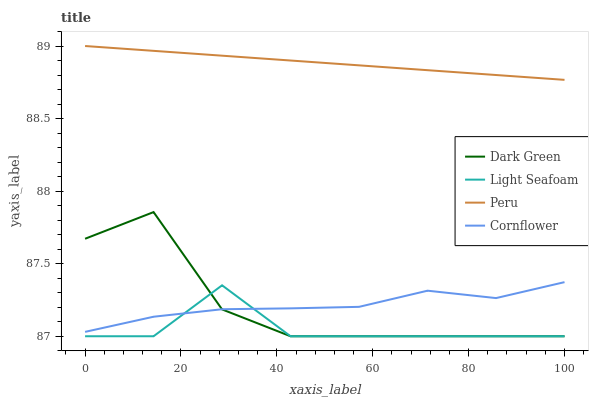Does Light Seafoam have the minimum area under the curve?
Answer yes or no. Yes. Does Peru have the maximum area under the curve?
Answer yes or no. Yes. Does Peru have the minimum area under the curve?
Answer yes or no. No. Does Light Seafoam have the maximum area under the curve?
Answer yes or no. No. Is Peru the smoothest?
Answer yes or no. Yes. Is Dark Green the roughest?
Answer yes or no. Yes. Is Light Seafoam the smoothest?
Answer yes or no. No. Is Light Seafoam the roughest?
Answer yes or no. No. Does Light Seafoam have the lowest value?
Answer yes or no. Yes. Does Peru have the lowest value?
Answer yes or no. No. Does Peru have the highest value?
Answer yes or no. Yes. Does Light Seafoam have the highest value?
Answer yes or no. No. Is Cornflower less than Peru?
Answer yes or no. Yes. Is Peru greater than Cornflower?
Answer yes or no. Yes. Does Light Seafoam intersect Cornflower?
Answer yes or no. Yes. Is Light Seafoam less than Cornflower?
Answer yes or no. No. Is Light Seafoam greater than Cornflower?
Answer yes or no. No. Does Cornflower intersect Peru?
Answer yes or no. No. 